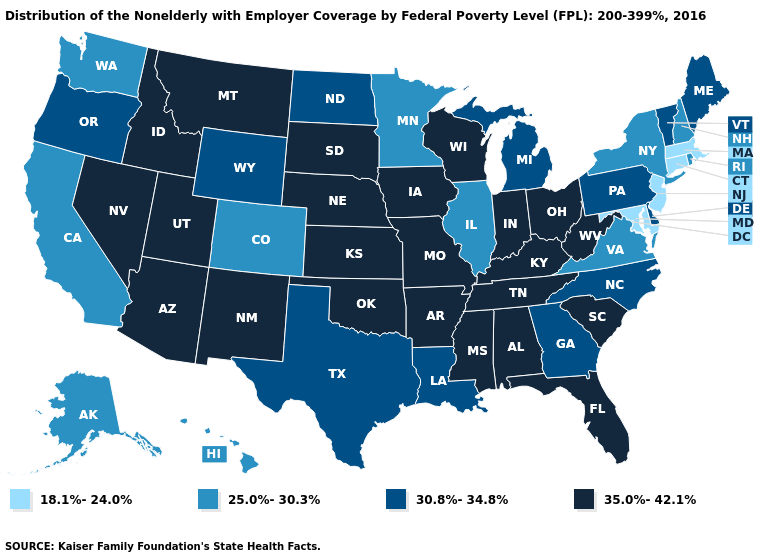What is the lowest value in the USA?
Keep it brief. 18.1%-24.0%. Which states have the highest value in the USA?
Short answer required. Alabama, Arizona, Arkansas, Florida, Idaho, Indiana, Iowa, Kansas, Kentucky, Mississippi, Missouri, Montana, Nebraska, Nevada, New Mexico, Ohio, Oklahoma, South Carolina, South Dakota, Tennessee, Utah, West Virginia, Wisconsin. Does California have the lowest value in the West?
Write a very short answer. Yes. Name the states that have a value in the range 30.8%-34.8%?
Quick response, please. Delaware, Georgia, Louisiana, Maine, Michigan, North Carolina, North Dakota, Oregon, Pennsylvania, Texas, Vermont, Wyoming. Among the states that border North Carolina , which have the lowest value?
Write a very short answer. Virginia. Does Massachusetts have the same value as Maryland?
Give a very brief answer. Yes. Among the states that border Ohio , does Pennsylvania have the highest value?
Keep it brief. No. Does New Hampshire have the lowest value in the Northeast?
Give a very brief answer. No. Name the states that have a value in the range 35.0%-42.1%?
Give a very brief answer. Alabama, Arizona, Arkansas, Florida, Idaho, Indiana, Iowa, Kansas, Kentucky, Mississippi, Missouri, Montana, Nebraska, Nevada, New Mexico, Ohio, Oklahoma, South Carolina, South Dakota, Tennessee, Utah, West Virginia, Wisconsin. Does Connecticut have the lowest value in the Northeast?
Answer briefly. Yes. What is the value of Wyoming?
Answer briefly. 30.8%-34.8%. Does West Virginia have the lowest value in the South?
Write a very short answer. No. Is the legend a continuous bar?
Short answer required. No. Among the states that border Rhode Island , which have the highest value?
Give a very brief answer. Connecticut, Massachusetts. What is the highest value in the USA?
Write a very short answer. 35.0%-42.1%. 